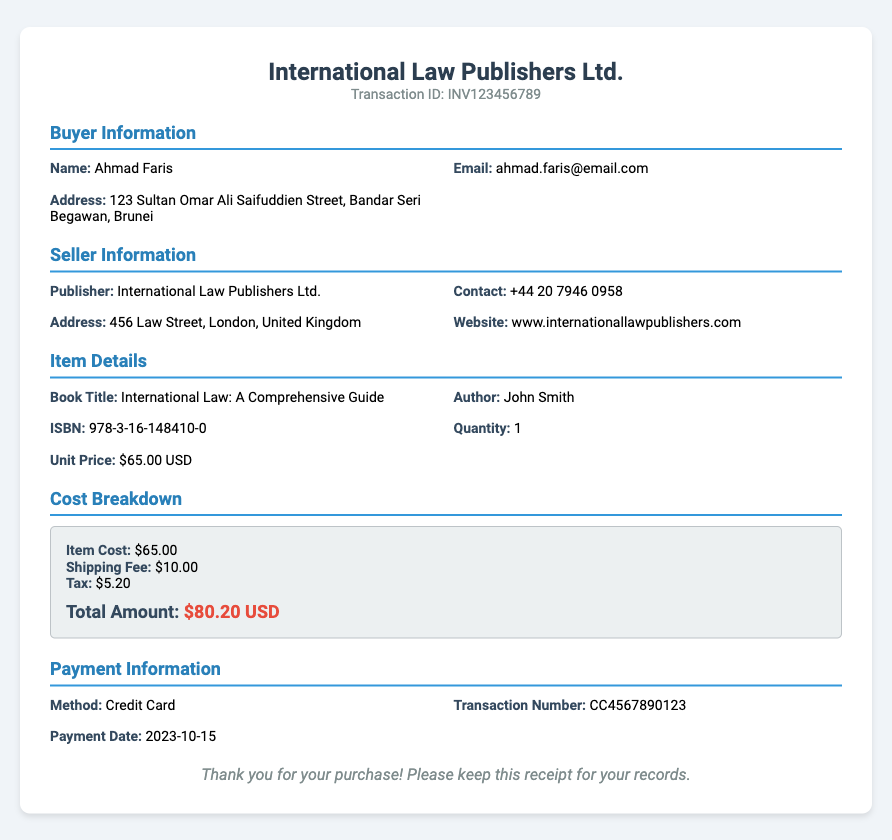What is the transaction ID? The transaction ID is clearly stated in the document and is an identifier for this particular transaction.
Answer: INV123456789 Who is the buyer? The buyer's name is included in the buyer information section.
Answer: Ahmad Faris What is the shipping fee? The shipping fee is specified in the cost breakdown section of the document.
Answer: $10.00 What is the ISBN of the book? The ISBN is mentioned under the item details, which uniquely identifies the book.
Answer: 978-3-16-148410-0 When was the payment date? The payment date is provided in the payment information section and indicates when the payment was processed.
Answer: 2023-10-15 How much tax was applied? The tax amount is included in the cost breakdown section and specifies the applied tax for the purchase.
Answer: $5.20 What is the total amount? The total amount is calculated based on item cost, shipping fee, and tax, and is listed in the cost breakdown section.
Answer: $80.20 USD What was the payment method? The payment information section outlines the method used for payment.
Answer: Credit Card Who is the seller? The seller's name is mentioned in the seller information section of the document.
Answer: International Law Publishers Ltd 